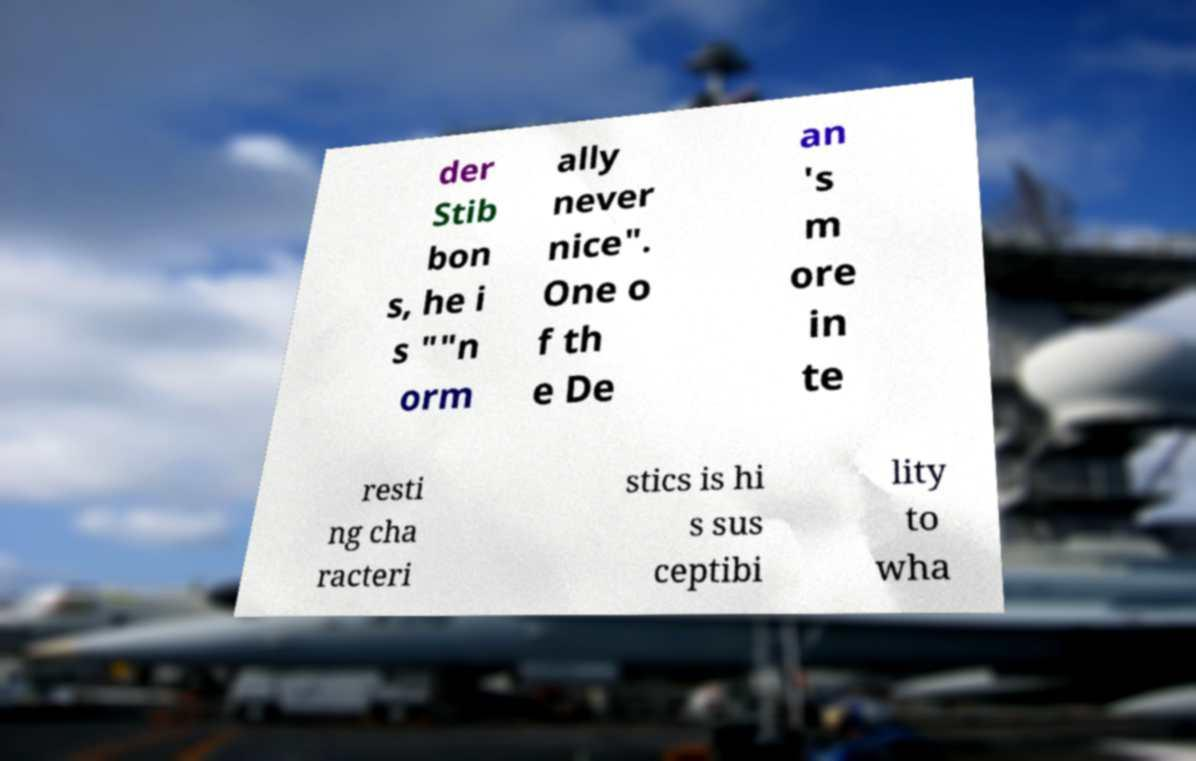There's text embedded in this image that I need extracted. Can you transcribe it verbatim? der Stib bon s, he i s ""n orm ally never nice". One o f th e De an 's m ore in te resti ng cha racteri stics is hi s sus ceptibi lity to wha 